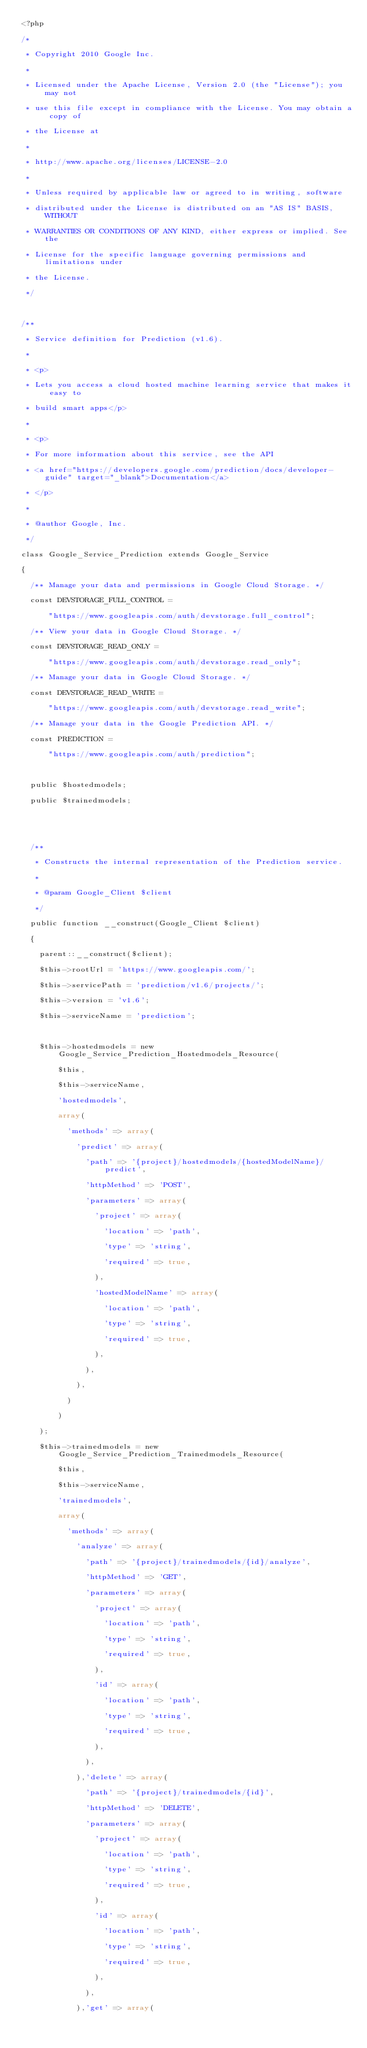Convert code to text. <code><loc_0><loc_0><loc_500><loc_500><_PHP_><?php
/*
 * Copyright 2010 Google Inc.
 *
 * Licensed under the Apache License, Version 2.0 (the "License"); you may not
 * use this file except in compliance with the License. You may obtain a copy of
 * the License at
 *
 * http://www.apache.org/licenses/LICENSE-2.0
 *
 * Unless required by applicable law or agreed to in writing, software
 * distributed under the License is distributed on an "AS IS" BASIS, WITHOUT
 * WARRANTIES OR CONDITIONS OF ANY KIND, either express or implied. See the
 * License for the specific language governing permissions and limitations under
 * the License.
 */

/**
 * Service definition for Prediction (v1.6).
 *
 * <p>
 * Lets you access a cloud hosted machine learning service that makes it easy to
 * build smart apps</p>
 *
 * <p>
 * For more information about this service, see the API
 * <a href="https://developers.google.com/prediction/docs/developer-guide" target="_blank">Documentation</a>
 * </p>
 *
 * @author Google, Inc.
 */
class Google_Service_Prediction extends Google_Service
{
  /** Manage your data and permissions in Google Cloud Storage. */
  const DEVSTORAGE_FULL_CONTROL =
      "https://www.googleapis.com/auth/devstorage.full_control";
  /** View your data in Google Cloud Storage. */
  const DEVSTORAGE_READ_ONLY =
      "https://www.googleapis.com/auth/devstorage.read_only";
  /** Manage your data in Google Cloud Storage. */
  const DEVSTORAGE_READ_WRITE =
      "https://www.googleapis.com/auth/devstorage.read_write";
  /** Manage your data in the Google Prediction API. */
  const PREDICTION =
      "https://www.googleapis.com/auth/prediction";

  public $hostedmodels;
  public $trainedmodels;
  

  /**
   * Constructs the internal representation of the Prediction service.
   *
   * @param Google_Client $client
   */
  public function __construct(Google_Client $client)
  {
    parent::__construct($client);
    $this->rootUrl = 'https://www.googleapis.com/';
    $this->servicePath = 'prediction/v1.6/projects/';
    $this->version = 'v1.6';
    $this->serviceName = 'prediction';

    $this->hostedmodels = new Google_Service_Prediction_Hostedmodels_Resource(
        $this,
        $this->serviceName,
        'hostedmodels',
        array(
          'methods' => array(
            'predict' => array(
              'path' => '{project}/hostedmodels/{hostedModelName}/predict',
              'httpMethod' => 'POST',
              'parameters' => array(
                'project' => array(
                  'location' => 'path',
                  'type' => 'string',
                  'required' => true,
                ),
                'hostedModelName' => array(
                  'location' => 'path',
                  'type' => 'string',
                  'required' => true,
                ),
              ),
            ),
          )
        )
    );
    $this->trainedmodels = new Google_Service_Prediction_Trainedmodels_Resource(
        $this,
        $this->serviceName,
        'trainedmodels',
        array(
          'methods' => array(
            'analyze' => array(
              'path' => '{project}/trainedmodels/{id}/analyze',
              'httpMethod' => 'GET',
              'parameters' => array(
                'project' => array(
                  'location' => 'path',
                  'type' => 'string',
                  'required' => true,
                ),
                'id' => array(
                  'location' => 'path',
                  'type' => 'string',
                  'required' => true,
                ),
              ),
            ),'delete' => array(
              'path' => '{project}/trainedmodels/{id}',
              'httpMethod' => 'DELETE',
              'parameters' => array(
                'project' => array(
                  'location' => 'path',
                  'type' => 'string',
                  'required' => true,
                ),
                'id' => array(
                  'location' => 'path',
                  'type' => 'string',
                  'required' => true,
                ),
              ),
            ),'get' => array(</code> 